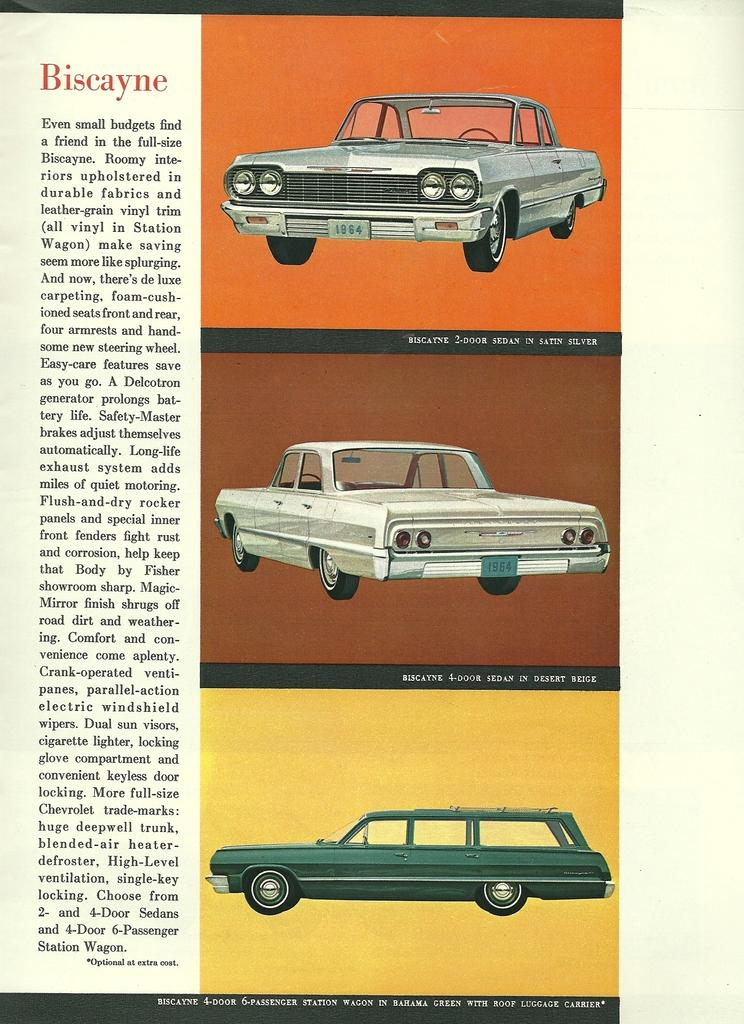How many cars are visible in the image? There are three cars in the image, arranged one below the other on the right side. Can you describe the arrangement of the cars in the image? The cars are arranged one below the other on the right side of the image. What is present on the left side of the image? There is some script on the left side of the image. What type of machine are the brothers competing against in the image? There are no machines or brothers present in the image; it only features three cars arranged on the right side and some script on the left side. 